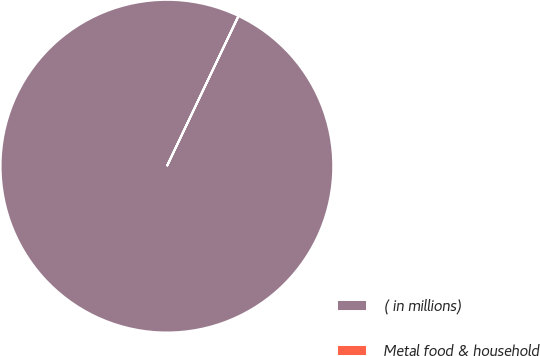<chart> <loc_0><loc_0><loc_500><loc_500><pie_chart><fcel>( in millions)<fcel>Metal food & household<nl><fcel>99.98%<fcel>0.02%<nl></chart> 